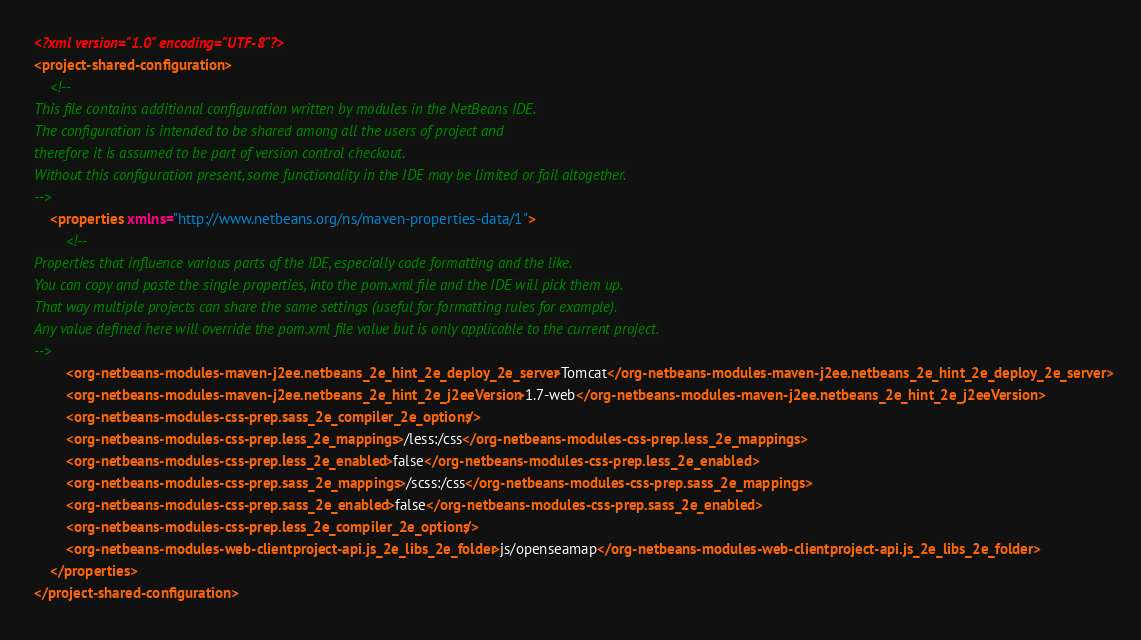<code> <loc_0><loc_0><loc_500><loc_500><_XML_><?xml version="1.0" encoding="UTF-8"?>
<project-shared-configuration>
    <!--
This file contains additional configuration written by modules in the NetBeans IDE.
The configuration is intended to be shared among all the users of project and
therefore it is assumed to be part of version control checkout.
Without this configuration present, some functionality in the IDE may be limited or fail altogether.
-->
    <properties xmlns="http://www.netbeans.org/ns/maven-properties-data/1">
        <!--
Properties that influence various parts of the IDE, especially code formatting and the like. 
You can copy and paste the single properties, into the pom.xml file and the IDE will pick them up.
That way multiple projects can share the same settings (useful for formatting rules for example).
Any value defined here will override the pom.xml file value but is only applicable to the current project.
-->
        <org-netbeans-modules-maven-j2ee.netbeans_2e_hint_2e_deploy_2e_server>Tomcat</org-netbeans-modules-maven-j2ee.netbeans_2e_hint_2e_deploy_2e_server>
        <org-netbeans-modules-maven-j2ee.netbeans_2e_hint_2e_j2eeVersion>1.7-web</org-netbeans-modules-maven-j2ee.netbeans_2e_hint_2e_j2eeVersion>
        <org-netbeans-modules-css-prep.sass_2e_compiler_2e_options/>
        <org-netbeans-modules-css-prep.less_2e_mappings>/less:/css</org-netbeans-modules-css-prep.less_2e_mappings>
        <org-netbeans-modules-css-prep.less_2e_enabled>false</org-netbeans-modules-css-prep.less_2e_enabled>
        <org-netbeans-modules-css-prep.sass_2e_mappings>/scss:/css</org-netbeans-modules-css-prep.sass_2e_mappings>
        <org-netbeans-modules-css-prep.sass_2e_enabled>false</org-netbeans-modules-css-prep.sass_2e_enabled>
        <org-netbeans-modules-css-prep.less_2e_compiler_2e_options/>
        <org-netbeans-modules-web-clientproject-api.js_2e_libs_2e_folder>js/openseamap</org-netbeans-modules-web-clientproject-api.js_2e_libs_2e_folder>
    </properties>
</project-shared-configuration>
</code> 